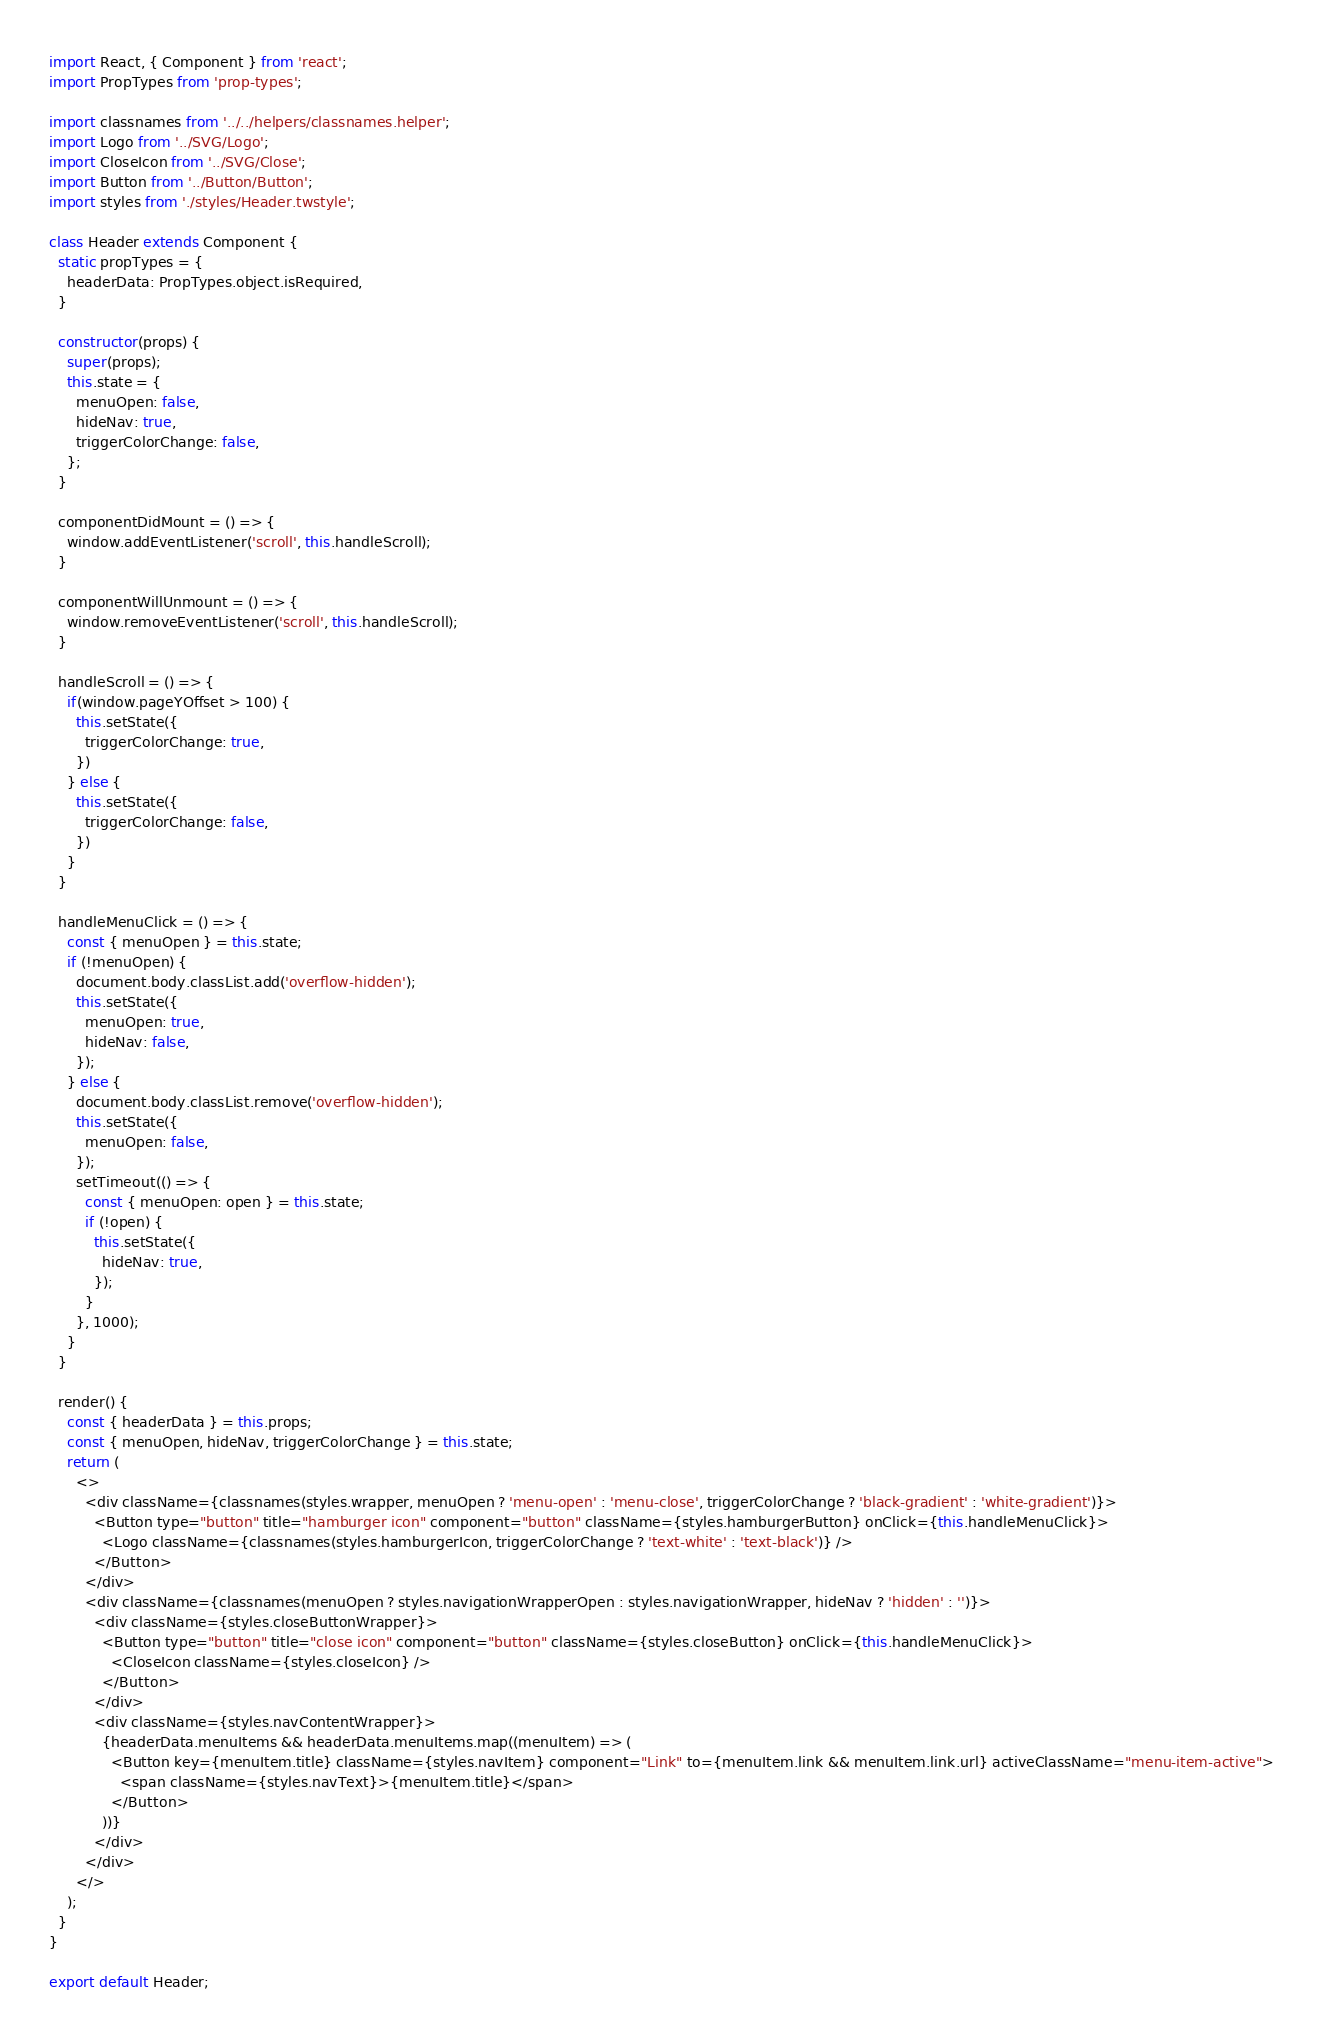Convert code to text. <code><loc_0><loc_0><loc_500><loc_500><_JavaScript_>import React, { Component } from 'react';
import PropTypes from 'prop-types';

import classnames from '../../helpers/classnames.helper';
import Logo from '../SVG/Logo';
import CloseIcon from '../SVG/Close';
import Button from '../Button/Button';
import styles from './styles/Header.twstyle';

class Header extends Component {
  static propTypes = {
    headerData: PropTypes.object.isRequired,
  }

  constructor(props) {
    super(props);
    this.state = {
      menuOpen: false,
      hideNav: true,
      triggerColorChange: false,
    };
  }

  componentDidMount = () => {
    window.addEventListener('scroll', this.handleScroll);
  }

  componentWillUnmount = () => {
    window.removeEventListener('scroll', this.handleScroll);
  }

  handleScroll = () => {
    if(window.pageYOffset > 100) {
      this.setState({
        triggerColorChange: true,
      })
    } else {
      this.setState({
        triggerColorChange: false,
      })
    }
  }

  handleMenuClick = () => {
    const { menuOpen } = this.state;
    if (!menuOpen) {
      document.body.classList.add('overflow-hidden');
      this.setState({
        menuOpen: true,
        hideNav: false,
      });
    } else {
      document.body.classList.remove('overflow-hidden');
      this.setState({
        menuOpen: false,
      });
      setTimeout(() => {
        const { menuOpen: open } = this.state;
        if (!open) {
          this.setState({
            hideNav: true,
          });
        }
      }, 1000);
    }
  }

  render() {
    const { headerData } = this.props;
    const { menuOpen, hideNav, triggerColorChange } = this.state;
    return (
      <>
        <div className={classnames(styles.wrapper, menuOpen ? 'menu-open' : 'menu-close', triggerColorChange ? 'black-gradient' : 'white-gradient')}>
          <Button type="button" title="hamburger icon" component="button" className={styles.hamburgerButton} onClick={this.handleMenuClick}>
            <Logo className={classnames(styles.hamburgerIcon, triggerColorChange ? 'text-white' : 'text-black')} />
          </Button>
        </div>
        <div className={classnames(menuOpen ? styles.navigationWrapperOpen : styles.navigationWrapper, hideNav ? 'hidden' : '')}>
          <div className={styles.closeButtonWrapper}>
            <Button type="button" title="close icon" component="button" className={styles.closeButton} onClick={this.handleMenuClick}>
              <CloseIcon className={styles.closeIcon} />
            </Button>
          </div>
          <div className={styles.navContentWrapper}>
            {headerData.menuItems && headerData.menuItems.map((menuItem) => (
              <Button key={menuItem.title} className={styles.navItem} component="Link" to={menuItem.link && menuItem.link.url} activeClassName="menu-item-active">
                <span className={styles.navText}>{menuItem.title}</span>
              </Button>
            ))}
          </div>
        </div>
      </>
    );
  }
}

export default Header;
</code> 